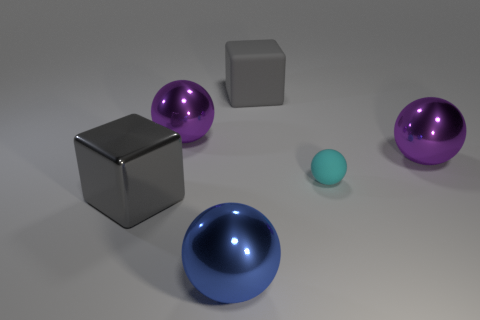Add 2 rubber objects. How many objects exist? 8 Subtract all spheres. How many objects are left? 2 Add 2 balls. How many balls are left? 6 Add 4 red metallic spheres. How many red metallic spheres exist? 4 Subtract 0 cyan cubes. How many objects are left? 6 Subtract all tiny gray spheres. Subtract all purple metal things. How many objects are left? 4 